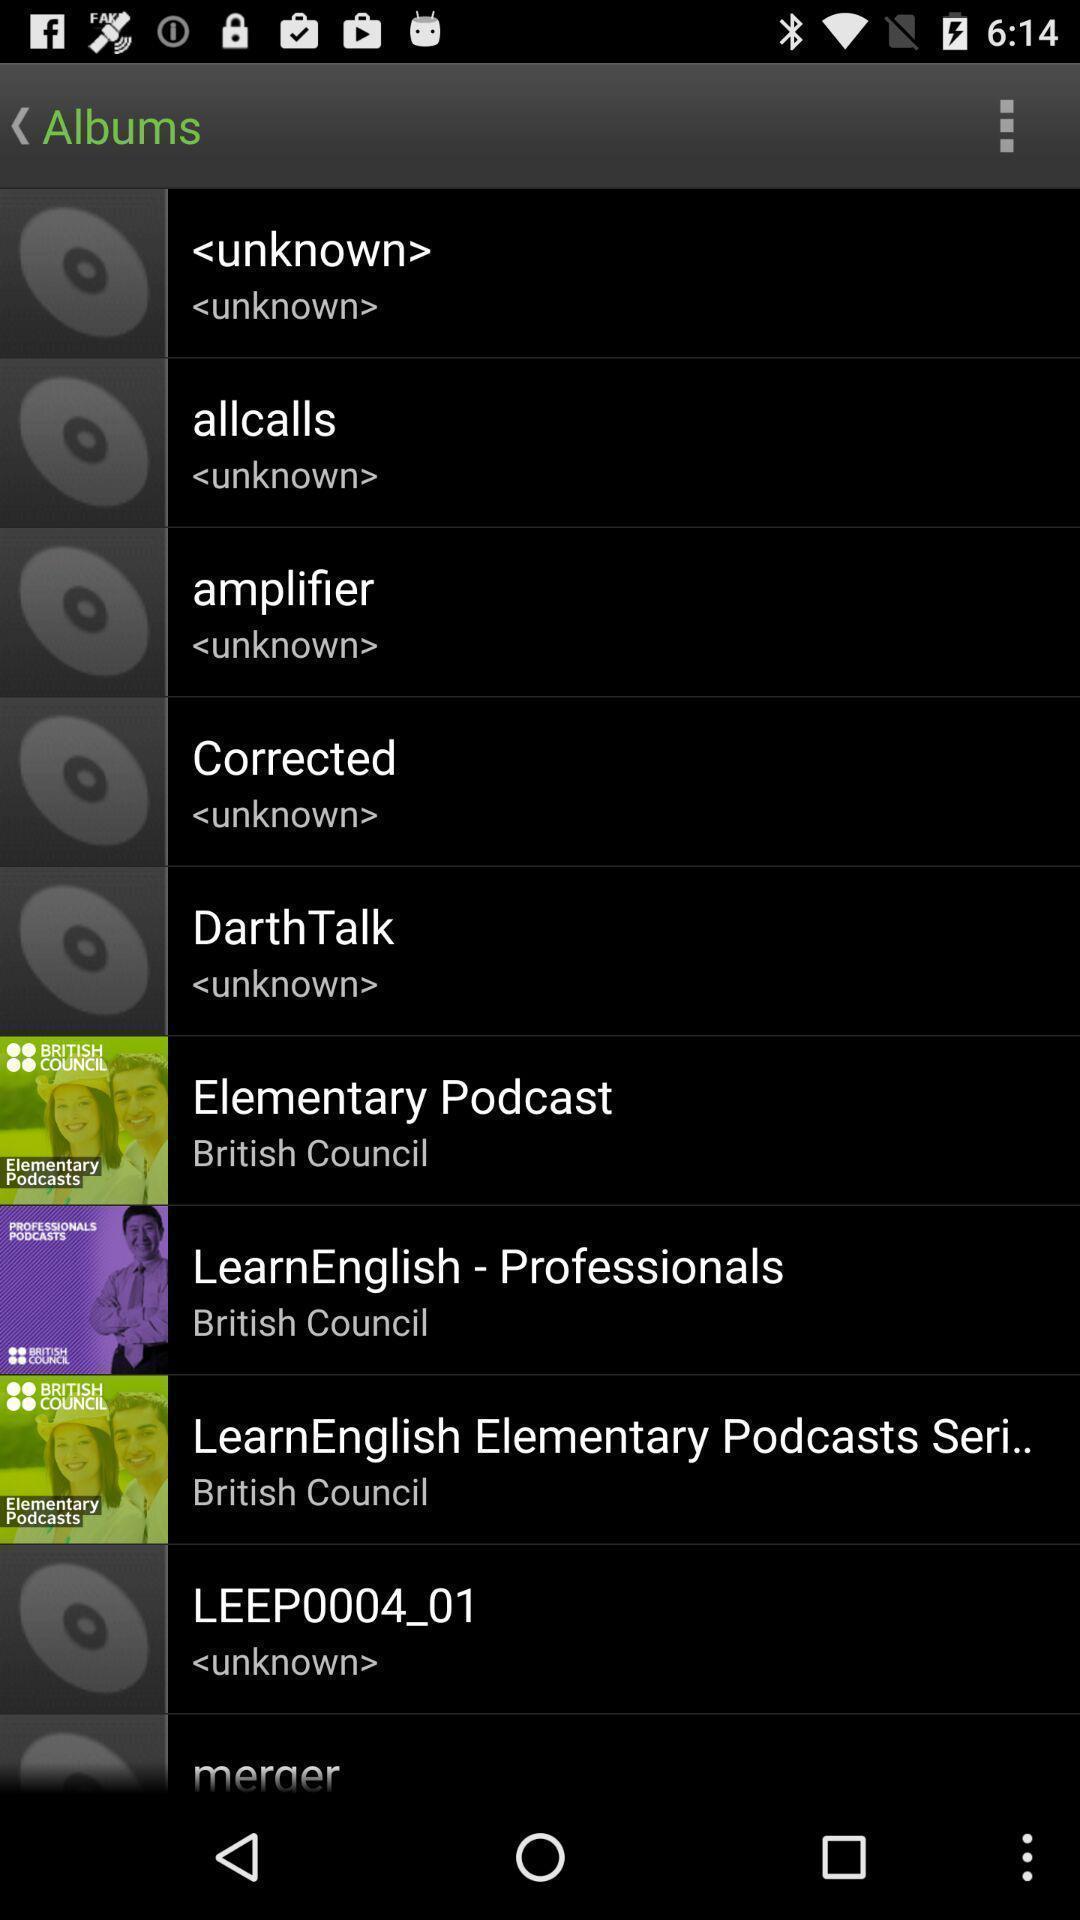Summarize the information in this screenshot. Page displaying various options in music application. 